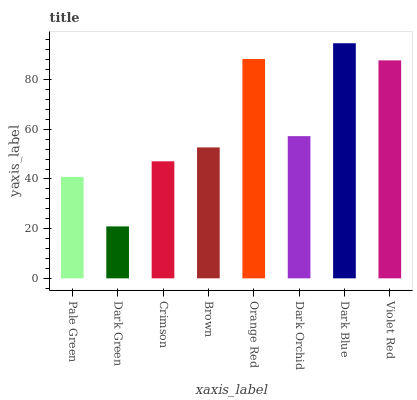Is Dark Green the minimum?
Answer yes or no. Yes. Is Dark Blue the maximum?
Answer yes or no. Yes. Is Crimson the minimum?
Answer yes or no. No. Is Crimson the maximum?
Answer yes or no. No. Is Crimson greater than Dark Green?
Answer yes or no. Yes. Is Dark Green less than Crimson?
Answer yes or no. Yes. Is Dark Green greater than Crimson?
Answer yes or no. No. Is Crimson less than Dark Green?
Answer yes or no. No. Is Dark Orchid the high median?
Answer yes or no. Yes. Is Brown the low median?
Answer yes or no. Yes. Is Crimson the high median?
Answer yes or no. No. Is Violet Red the low median?
Answer yes or no. No. 